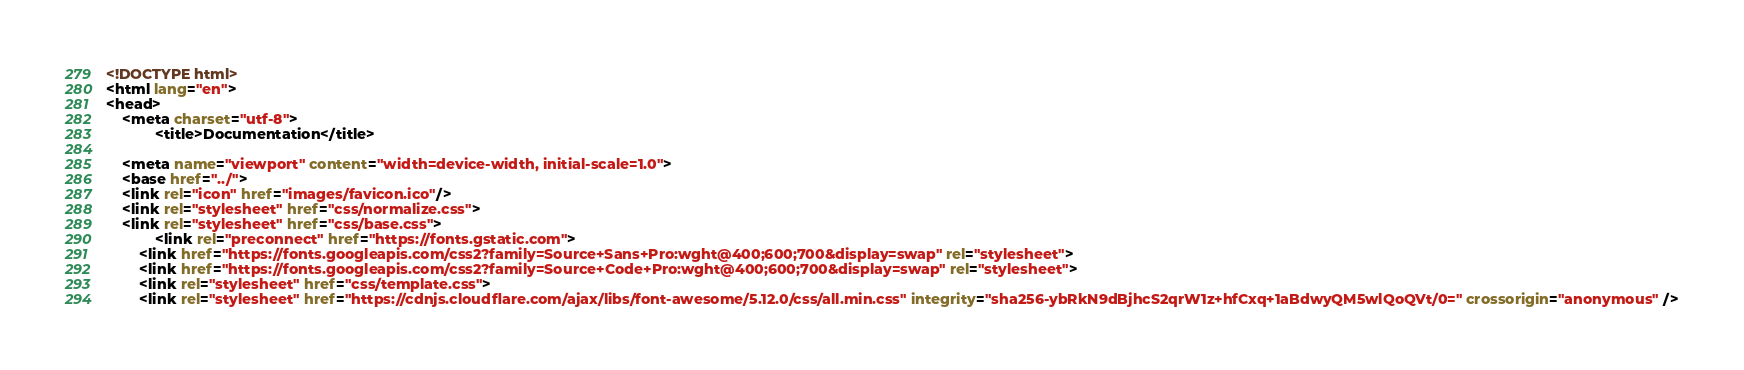<code> <loc_0><loc_0><loc_500><loc_500><_HTML_><!DOCTYPE html>
<html lang="en">
<head>
    <meta charset="utf-8">
            <title>Documentation</title>
    
    <meta name="viewport" content="width=device-width, initial-scale=1.0">
    <base href="../">
    <link rel="icon" href="images/favicon.ico"/>
    <link rel="stylesheet" href="css/normalize.css">
    <link rel="stylesheet" href="css/base.css">
            <link rel="preconnect" href="https://fonts.gstatic.com">
        <link href="https://fonts.googleapis.com/css2?family=Source+Sans+Pro:wght@400;600;700&display=swap" rel="stylesheet">
        <link href="https://fonts.googleapis.com/css2?family=Source+Code+Pro:wght@400;600;700&display=swap" rel="stylesheet">
        <link rel="stylesheet" href="css/template.css">
        <link rel="stylesheet" href="https://cdnjs.cloudflare.com/ajax/libs/font-awesome/5.12.0/css/all.min.css" integrity="sha256-ybRkN9dBjhcS2qrW1z+hfCxq+1aBdwyQM5wlQoQVt/0=" crossorigin="anonymous" /></code> 